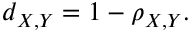Convert formula to latex. <formula><loc_0><loc_0><loc_500><loc_500>d _ { X , Y } = 1 - \rho _ { X , Y } .</formula> 